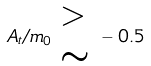<formula> <loc_0><loc_0><loc_500><loc_500>A _ { t } / m _ { 0 } { \begin{array} { l } > \\ \sim \end{array} } - 0 . 5</formula> 